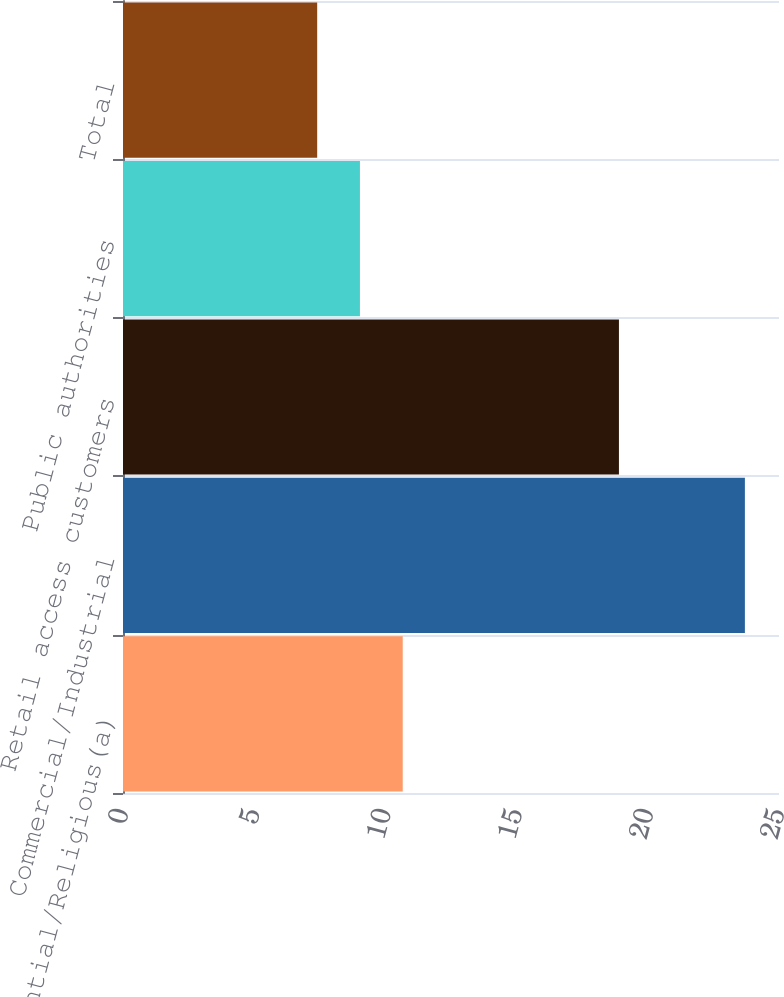Convert chart to OTSL. <chart><loc_0><loc_0><loc_500><loc_500><bar_chart><fcel>Residential/Religious(a)<fcel>Commercial/Industrial<fcel>Retail access customers<fcel>Public authorities<fcel>Total<nl><fcel>10.66<fcel>23.7<fcel>18.9<fcel>9.03<fcel>7.4<nl></chart> 